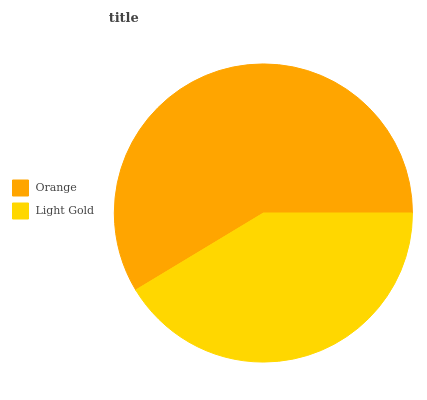Is Light Gold the minimum?
Answer yes or no. Yes. Is Orange the maximum?
Answer yes or no. Yes. Is Light Gold the maximum?
Answer yes or no. No. Is Orange greater than Light Gold?
Answer yes or no. Yes. Is Light Gold less than Orange?
Answer yes or no. Yes. Is Light Gold greater than Orange?
Answer yes or no. No. Is Orange less than Light Gold?
Answer yes or no. No. Is Orange the high median?
Answer yes or no. Yes. Is Light Gold the low median?
Answer yes or no. Yes. Is Light Gold the high median?
Answer yes or no. No. Is Orange the low median?
Answer yes or no. No. 